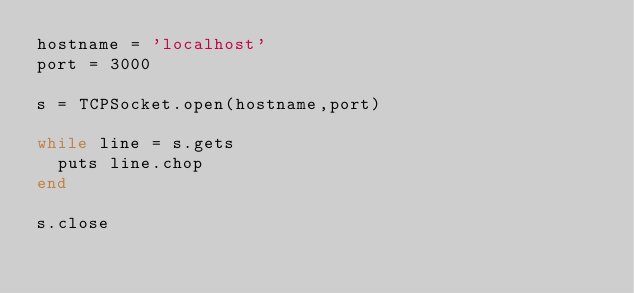<code> <loc_0><loc_0><loc_500><loc_500><_Ruby_>hostname = 'localhost'
port = 3000

s = TCPSocket.open(hostname,port)

while line = s.gets
  puts line.chop
end

s.close</code> 